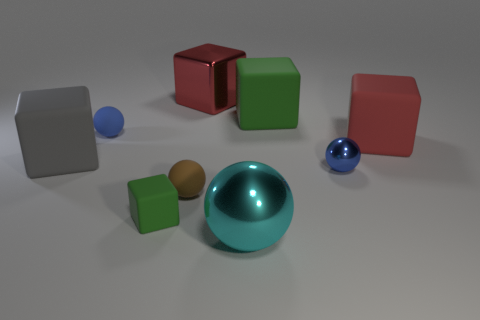How does the lighting in the scene affect the appearance of the objects? The lighting in the scene has a diffused source, softly illuminating the objects and creating gentle shadows that give a sense of depth and volume. The reflective surfaces of the spheres and cubes catch the light, highlighting their glossy textures and enhancing the realism of the scene. 